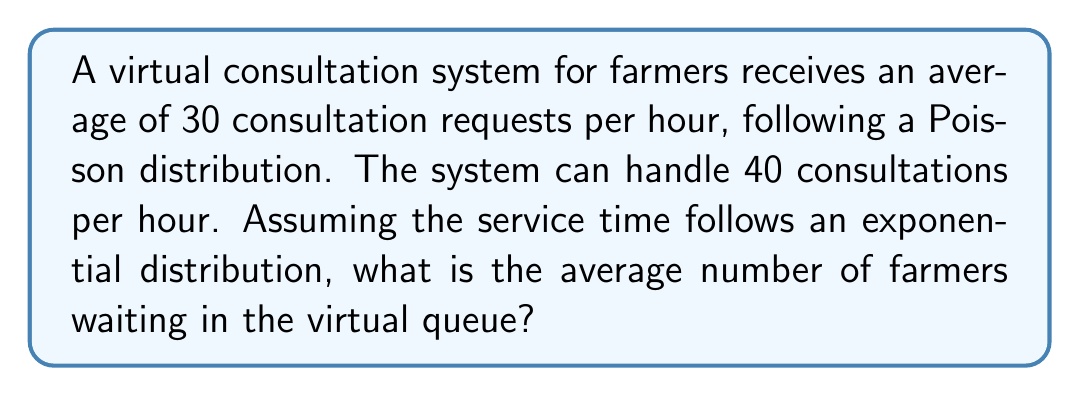Can you answer this question? To solve this problem, we'll use the M/M/1 queueing model, where:

1. M: Arrival process is Markovian (Poisson)
2. M: Service times are Markovian (exponential)
3. 1: Single server system

Step 1: Define the variables
Let $\lambda$ be the arrival rate and $\mu$ be the service rate.
$\lambda = 30$ consultations/hour
$\mu = 40$ consultations/hour

Step 2: Calculate the utilization factor $\rho$
$$\rho = \frac{\lambda}{\mu} = \frac{30}{40} = 0.75$$

Step 3: Calculate the average number of farmers in the system $L$
For an M/M/1 queue, the formula is:
$$L = \frac{\rho}{1-\rho} = \frac{0.75}{1-0.75} = 3$$

Step 4: Calculate the average number of farmers waiting in the queue $L_q$
$$L_q = L - \rho = 3 - 0.75 = 2.25$$

Therefore, the average number of farmers waiting in the virtual queue is 2.25.
Answer: 2.25 farmers 